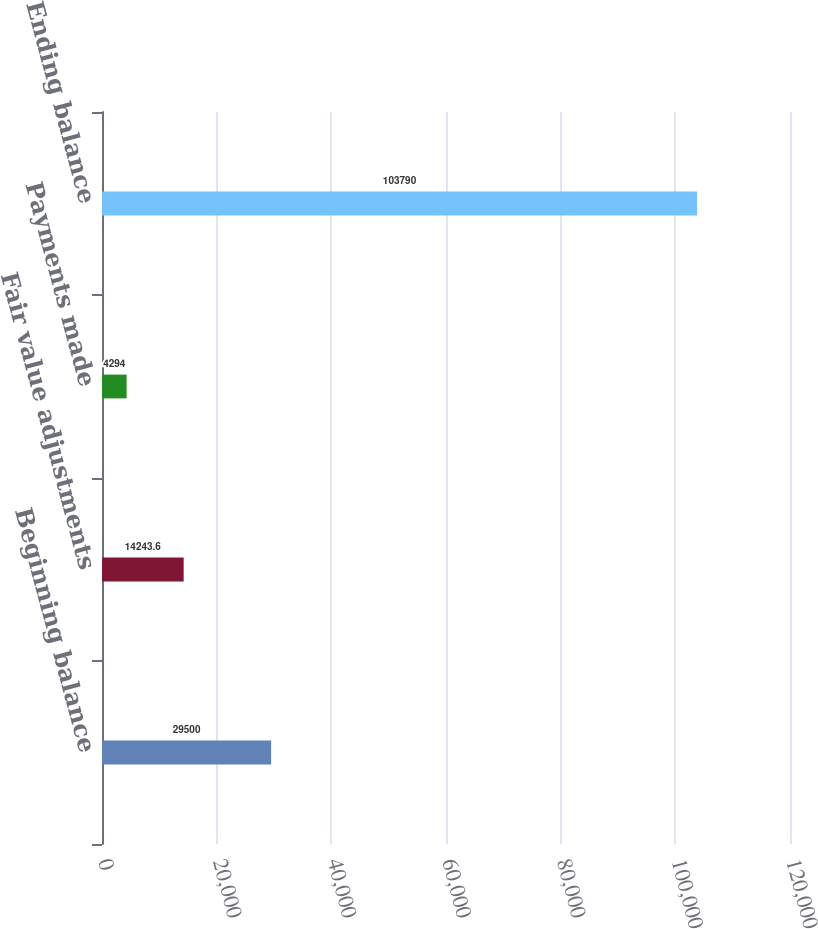Convert chart to OTSL. <chart><loc_0><loc_0><loc_500><loc_500><bar_chart><fcel>Beginning balance<fcel>Fair value adjustments<fcel>Payments made<fcel>Ending balance<nl><fcel>29500<fcel>14243.6<fcel>4294<fcel>103790<nl></chart> 